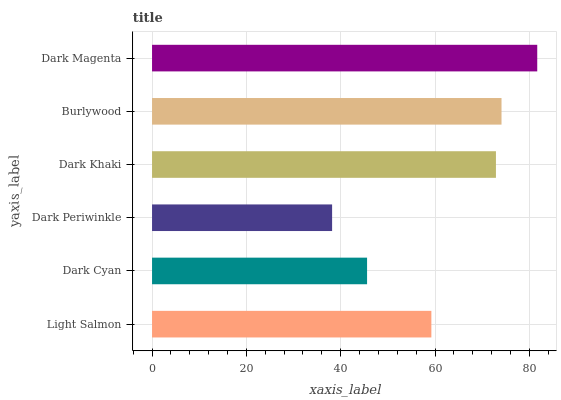Is Dark Periwinkle the minimum?
Answer yes or no. Yes. Is Dark Magenta the maximum?
Answer yes or no. Yes. Is Dark Cyan the minimum?
Answer yes or no. No. Is Dark Cyan the maximum?
Answer yes or no. No. Is Light Salmon greater than Dark Cyan?
Answer yes or no. Yes. Is Dark Cyan less than Light Salmon?
Answer yes or no. Yes. Is Dark Cyan greater than Light Salmon?
Answer yes or no. No. Is Light Salmon less than Dark Cyan?
Answer yes or no. No. Is Dark Khaki the high median?
Answer yes or no. Yes. Is Light Salmon the low median?
Answer yes or no. Yes. Is Dark Periwinkle the high median?
Answer yes or no. No. Is Burlywood the low median?
Answer yes or no. No. 